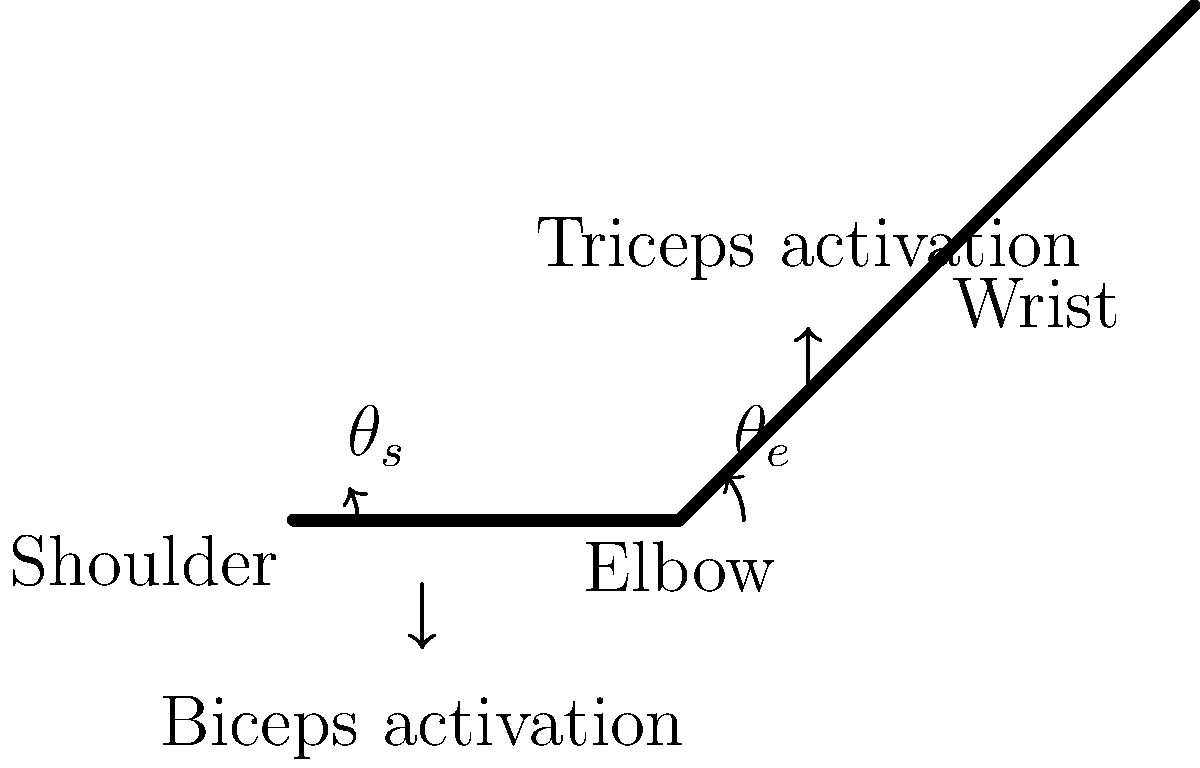During a forehand stroke in tennis, which joint angle typically experiences the greatest change, and which muscle group shows the highest activation level? To answer this question, let's analyze the biomechanics of a tennis forehand stroke:

1. Joint angles:
   a) Shoulder ($\theta_s$): The shoulder joint rotates significantly during the forehand stroke, typically ranging from 0° to about 90° or more.
   b) Elbow ($\theta_e$): The elbow joint also changes angle, usually starting at around 90° and extending to nearly 180° at contact.

2. Muscle activation:
   a) Biceps: Activated during the preparation phase to flex the elbow.
   b) Triceps: Highly activated during the forward swing and contact phase to extend the elbow rapidly.

3. Analysis:
   - The shoulder joint generally experiences a larger angular change compared to the elbow during a forehand stroke. The shoulder rotation can exceed 90°, while the elbow typically changes by about 90°.
   - The triceps show the highest activation level during the forward swing and contact phase, as they are responsible for the explosive extension of the elbow, which is crucial for generating power in the stroke.

4. Thiago Monteiro's playing style:
   As a professional tennis player known for his powerful groundstrokes, Monteiro likely exhibits significant shoulder rotation and high triceps activation during his forehand strokes.

Given this analysis, we can conclude that the shoulder joint experiences the greatest change in angle, and the triceps muscle group shows the highest activation level during a typical forehand stroke.
Answer: Shoulder joint (greatest angle change); Triceps (highest activation) 